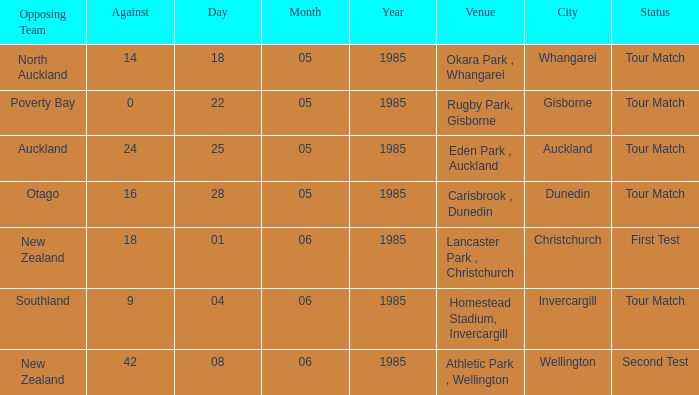Could you help me parse every detail presented in this table? {'header': ['Opposing Team', 'Against', 'Day', 'Month', 'Year', 'Venue', 'City', 'Status'], 'rows': [['North Auckland', '14', '18', '05', '1985', 'Okara Park , Whangarei', 'Whangarei', 'Tour Match'], ['Poverty Bay', '0', '22', '05', '1985', 'Rugby Park, Gisborne', 'Gisborne', 'Tour Match'], ['Auckland', '24', '25', '05', '1985', 'Eden Park , Auckland', 'Auckland', 'Tour Match'], ['Otago', '16', '28', '05', '1985', 'Carisbrook , Dunedin', 'Dunedin', 'Tour Match'], ['New Zealand', '18', '01', '06', '1985', 'Lancaster Park , Christchurch', 'Christchurch', 'First Test'], ['Southland', '9', '04', '06', '1985', 'Homestead Stadium, Invercargill', 'Invercargill', 'Tour Match'], ['New Zealand', '42', '08', '06', '1985', 'Athletic Park , Wellington', 'Wellington', 'Second Test']]} What date was the opposing team Poverty Bay? 22/05/1985. 